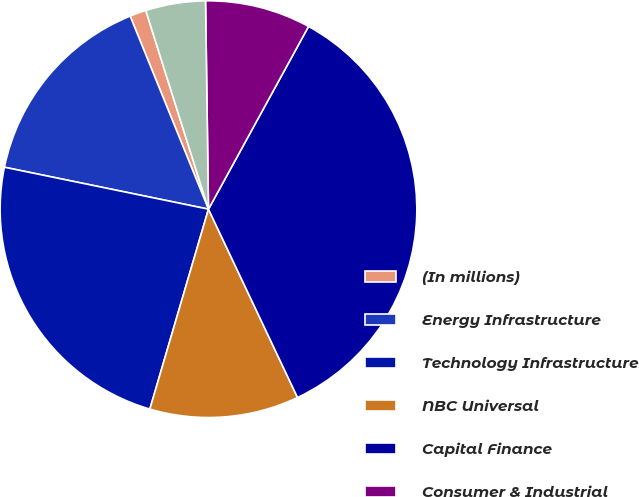<chart> <loc_0><loc_0><loc_500><loc_500><pie_chart><fcel>(In millions)<fcel>Energy Infrastructure<fcel>Technology Infrastructure<fcel>NBC Universal<fcel>Capital Finance<fcel>Consumer & Industrial<fcel>Corporate items and<nl><fcel>1.27%<fcel>15.64%<fcel>23.69%<fcel>11.57%<fcel>35.0%<fcel>8.2%<fcel>4.64%<nl></chart> 